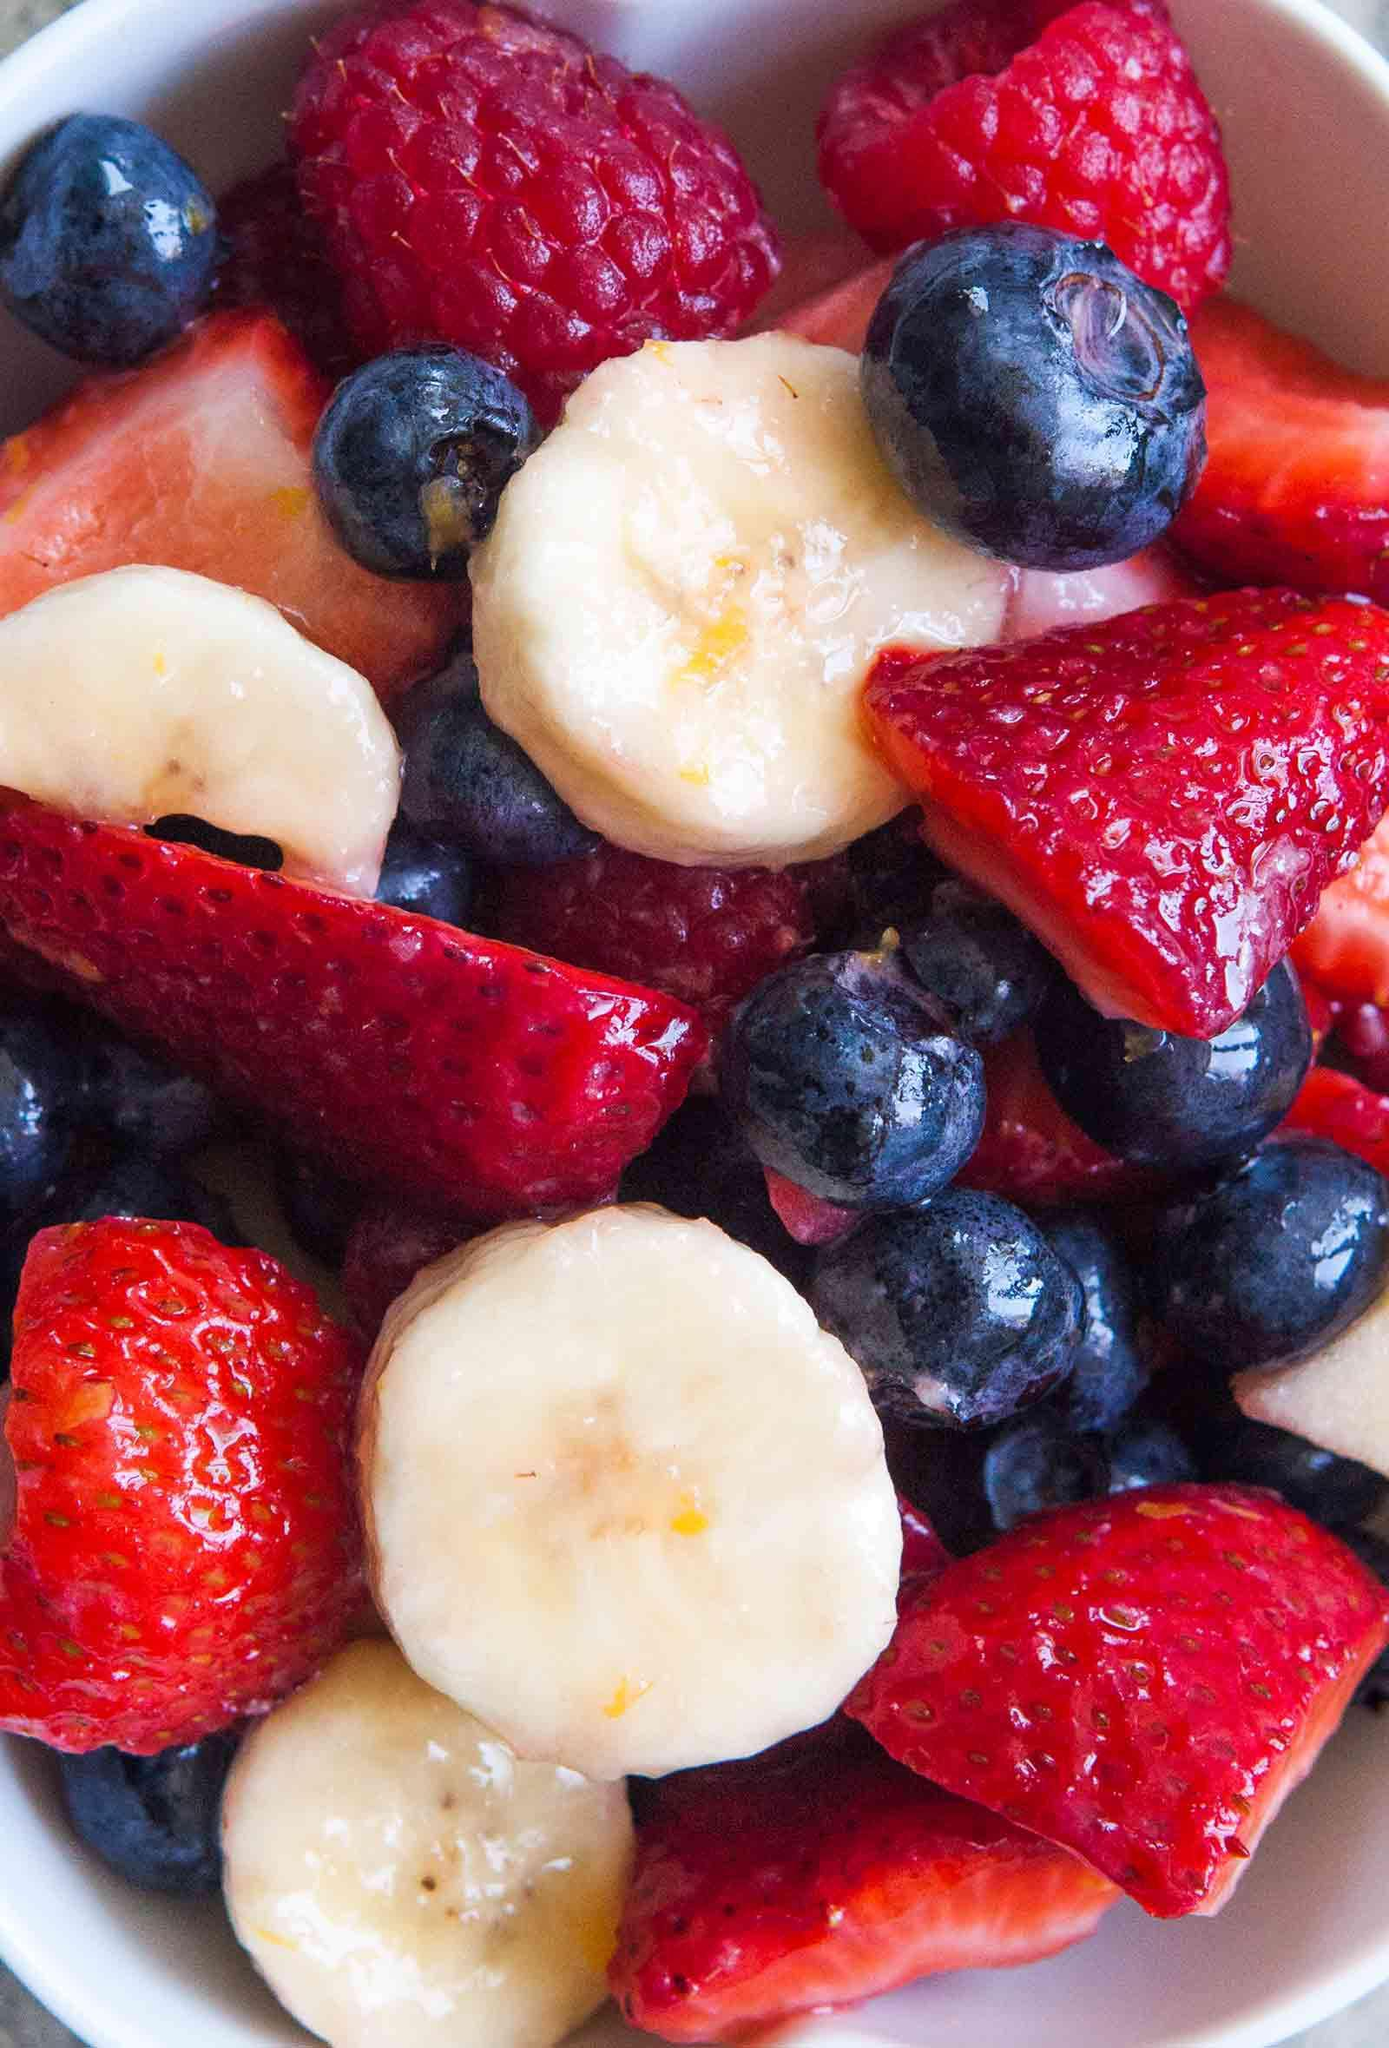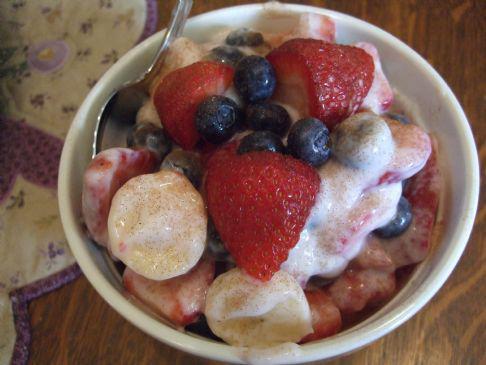The first image is the image on the left, the second image is the image on the right. Examine the images to the left and right. Is the description "A banana with its peel on is next to a bunch of reddish grapes in the right image." accurate? Answer yes or no. No. The first image is the image on the left, the second image is the image on the right. Examine the images to the left and right. Is the description "Some of the fruit is clearly in a bowl." accurate? Answer yes or no. Yes. 